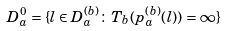Convert formula to latex. <formula><loc_0><loc_0><loc_500><loc_500>D _ { a } ^ { 0 } = \{ l \in D _ { a } ^ { ( b ) } \colon T _ { b } ( p ^ { ( b ) } _ { a } ( l ) ) = \infty \}</formula> 